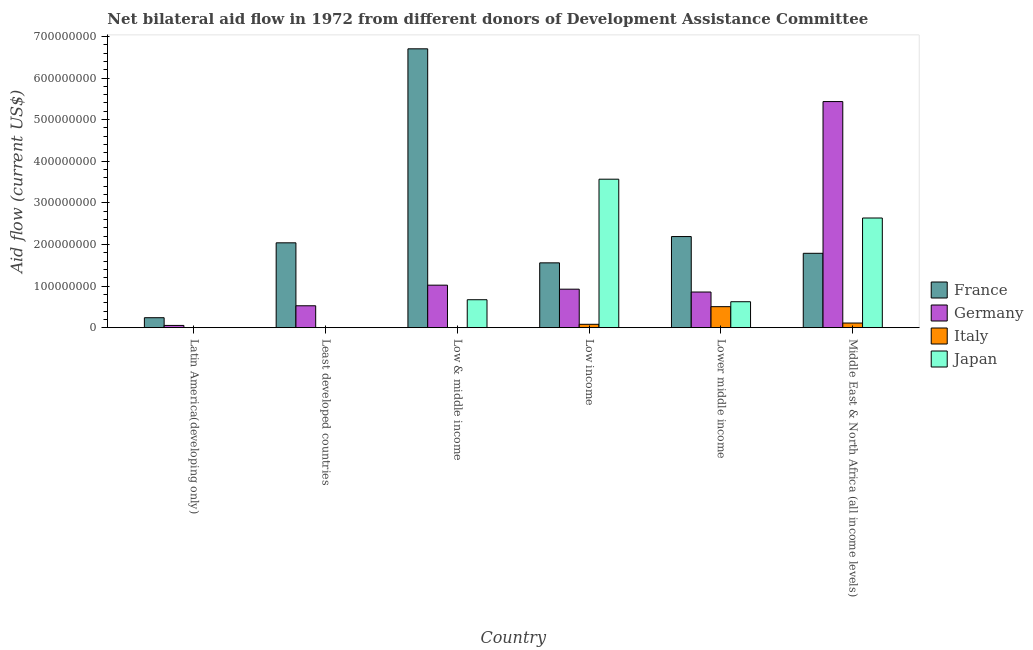How many different coloured bars are there?
Provide a succinct answer. 4. How many groups of bars are there?
Your response must be concise. 6. Are the number of bars on each tick of the X-axis equal?
Your answer should be very brief. No. How many bars are there on the 3rd tick from the right?
Provide a succinct answer. 4. What is the label of the 5th group of bars from the left?
Your answer should be compact. Lower middle income. What is the amount of aid given by italy in Latin America(developing only)?
Offer a very short reply. 1.80e+05. Across all countries, what is the maximum amount of aid given by france?
Provide a succinct answer. 6.70e+08. Across all countries, what is the minimum amount of aid given by italy?
Provide a short and direct response. 0. In which country was the amount of aid given by italy maximum?
Keep it short and to the point. Lower middle income. What is the total amount of aid given by japan in the graph?
Ensure brevity in your answer.  7.50e+08. What is the difference between the amount of aid given by japan in Lower middle income and that in Middle East & North Africa (all income levels)?
Provide a succinct answer. -2.01e+08. What is the difference between the amount of aid given by japan in Lower middle income and the amount of aid given by germany in Latin America(developing only)?
Provide a succinct answer. 5.70e+07. What is the average amount of aid given by germany per country?
Provide a succinct answer. 1.47e+08. What is the difference between the amount of aid given by germany and amount of aid given by japan in Middle East & North Africa (all income levels)?
Offer a terse response. 2.80e+08. In how many countries, is the amount of aid given by germany greater than 660000000 US$?
Give a very brief answer. 0. What is the ratio of the amount of aid given by germany in Lower middle income to that in Middle East & North Africa (all income levels)?
Keep it short and to the point. 0.16. Is the amount of aid given by germany in Least developed countries less than that in Low & middle income?
Give a very brief answer. Yes. What is the difference between the highest and the second highest amount of aid given by japan?
Your answer should be very brief. 9.33e+07. What is the difference between the highest and the lowest amount of aid given by germany?
Give a very brief answer. 5.38e+08. Is the sum of the amount of aid given by italy in Low income and Lower middle income greater than the maximum amount of aid given by germany across all countries?
Provide a short and direct response. No. Are all the bars in the graph horizontal?
Make the answer very short. No. How many countries are there in the graph?
Keep it short and to the point. 6. Does the graph contain any zero values?
Your answer should be compact. Yes. Does the graph contain grids?
Give a very brief answer. No. Where does the legend appear in the graph?
Ensure brevity in your answer.  Center right. How many legend labels are there?
Keep it short and to the point. 4. How are the legend labels stacked?
Your answer should be very brief. Vertical. What is the title of the graph?
Keep it short and to the point. Net bilateral aid flow in 1972 from different donors of Development Assistance Committee. What is the Aid flow (current US$) in France in Latin America(developing only)?
Your response must be concise. 2.39e+07. What is the Aid flow (current US$) of Germany in Latin America(developing only)?
Keep it short and to the point. 5.36e+06. What is the Aid flow (current US$) of France in Least developed countries?
Ensure brevity in your answer.  2.04e+08. What is the Aid flow (current US$) in Germany in Least developed countries?
Your answer should be compact. 5.26e+07. What is the Aid flow (current US$) in Italy in Least developed countries?
Your answer should be compact. 0. What is the Aid flow (current US$) in Japan in Least developed countries?
Provide a short and direct response. 0. What is the Aid flow (current US$) in France in Low & middle income?
Your response must be concise. 6.70e+08. What is the Aid flow (current US$) in Germany in Low & middle income?
Your response must be concise. 1.02e+08. What is the Aid flow (current US$) in Japan in Low & middle income?
Give a very brief answer. 6.71e+07. What is the Aid flow (current US$) of France in Low income?
Give a very brief answer. 1.56e+08. What is the Aid flow (current US$) of Germany in Low income?
Your response must be concise. 9.25e+07. What is the Aid flow (current US$) of Italy in Low income?
Your answer should be compact. 8.06e+06. What is the Aid flow (current US$) of Japan in Low income?
Offer a terse response. 3.57e+08. What is the Aid flow (current US$) of France in Lower middle income?
Offer a terse response. 2.19e+08. What is the Aid flow (current US$) of Germany in Lower middle income?
Your response must be concise. 8.56e+07. What is the Aid flow (current US$) in Italy in Lower middle income?
Offer a very short reply. 5.05e+07. What is the Aid flow (current US$) in Japan in Lower middle income?
Make the answer very short. 6.23e+07. What is the Aid flow (current US$) in France in Middle East & North Africa (all income levels)?
Keep it short and to the point. 1.79e+08. What is the Aid flow (current US$) of Germany in Middle East & North Africa (all income levels)?
Provide a short and direct response. 5.43e+08. What is the Aid flow (current US$) of Italy in Middle East & North Africa (all income levels)?
Provide a succinct answer. 1.11e+07. What is the Aid flow (current US$) in Japan in Middle East & North Africa (all income levels)?
Offer a terse response. 2.64e+08. Across all countries, what is the maximum Aid flow (current US$) in France?
Your answer should be compact. 6.70e+08. Across all countries, what is the maximum Aid flow (current US$) in Germany?
Provide a short and direct response. 5.43e+08. Across all countries, what is the maximum Aid flow (current US$) of Italy?
Provide a succinct answer. 5.05e+07. Across all countries, what is the maximum Aid flow (current US$) of Japan?
Ensure brevity in your answer.  3.57e+08. Across all countries, what is the minimum Aid flow (current US$) in France?
Your response must be concise. 2.39e+07. Across all countries, what is the minimum Aid flow (current US$) in Germany?
Ensure brevity in your answer.  5.36e+06. What is the total Aid flow (current US$) of France in the graph?
Provide a short and direct response. 1.45e+09. What is the total Aid flow (current US$) of Germany in the graph?
Keep it short and to the point. 8.82e+08. What is the total Aid flow (current US$) of Italy in the graph?
Your answer should be compact. 6.98e+07. What is the total Aid flow (current US$) in Japan in the graph?
Keep it short and to the point. 7.50e+08. What is the difference between the Aid flow (current US$) in France in Latin America(developing only) and that in Least developed countries?
Keep it short and to the point. -1.80e+08. What is the difference between the Aid flow (current US$) in Germany in Latin America(developing only) and that in Least developed countries?
Your response must be concise. -4.73e+07. What is the difference between the Aid flow (current US$) of France in Latin America(developing only) and that in Low & middle income?
Offer a very short reply. -6.46e+08. What is the difference between the Aid flow (current US$) in Germany in Latin America(developing only) and that in Low & middle income?
Make the answer very short. -9.68e+07. What is the difference between the Aid flow (current US$) of France in Latin America(developing only) and that in Low income?
Your answer should be very brief. -1.32e+08. What is the difference between the Aid flow (current US$) of Germany in Latin America(developing only) and that in Low income?
Make the answer very short. -8.71e+07. What is the difference between the Aid flow (current US$) in Italy in Latin America(developing only) and that in Low income?
Your answer should be compact. -7.88e+06. What is the difference between the Aid flow (current US$) in France in Latin America(developing only) and that in Lower middle income?
Provide a succinct answer. -1.95e+08. What is the difference between the Aid flow (current US$) of Germany in Latin America(developing only) and that in Lower middle income?
Your response must be concise. -8.03e+07. What is the difference between the Aid flow (current US$) of Italy in Latin America(developing only) and that in Lower middle income?
Your answer should be very brief. -5.03e+07. What is the difference between the Aid flow (current US$) in France in Latin America(developing only) and that in Middle East & North Africa (all income levels)?
Your answer should be compact. -1.55e+08. What is the difference between the Aid flow (current US$) in Germany in Latin America(developing only) and that in Middle East & North Africa (all income levels)?
Provide a short and direct response. -5.38e+08. What is the difference between the Aid flow (current US$) in Italy in Latin America(developing only) and that in Middle East & North Africa (all income levels)?
Your answer should be very brief. -1.09e+07. What is the difference between the Aid flow (current US$) of France in Least developed countries and that in Low & middle income?
Your response must be concise. -4.66e+08. What is the difference between the Aid flow (current US$) in Germany in Least developed countries and that in Low & middle income?
Your response must be concise. -4.95e+07. What is the difference between the Aid flow (current US$) in France in Least developed countries and that in Low income?
Your answer should be very brief. 4.81e+07. What is the difference between the Aid flow (current US$) in Germany in Least developed countries and that in Low income?
Your answer should be compact. -3.99e+07. What is the difference between the Aid flow (current US$) in France in Least developed countries and that in Lower middle income?
Offer a terse response. -1.51e+07. What is the difference between the Aid flow (current US$) of Germany in Least developed countries and that in Lower middle income?
Offer a very short reply. -3.30e+07. What is the difference between the Aid flow (current US$) in France in Least developed countries and that in Middle East & North Africa (all income levels)?
Offer a very short reply. 2.52e+07. What is the difference between the Aid flow (current US$) in Germany in Least developed countries and that in Middle East & North Africa (all income levels)?
Provide a short and direct response. -4.91e+08. What is the difference between the Aid flow (current US$) of France in Low & middle income and that in Low income?
Provide a short and direct response. 5.14e+08. What is the difference between the Aid flow (current US$) in Germany in Low & middle income and that in Low income?
Ensure brevity in your answer.  9.65e+06. What is the difference between the Aid flow (current US$) of Japan in Low & middle income and that in Low income?
Offer a very short reply. -2.90e+08. What is the difference between the Aid flow (current US$) of France in Low & middle income and that in Lower middle income?
Provide a succinct answer. 4.51e+08. What is the difference between the Aid flow (current US$) in Germany in Low & middle income and that in Lower middle income?
Your answer should be very brief. 1.65e+07. What is the difference between the Aid flow (current US$) in Japan in Low & middle income and that in Lower middle income?
Offer a very short reply. 4.79e+06. What is the difference between the Aid flow (current US$) in France in Low & middle income and that in Middle East & North Africa (all income levels)?
Keep it short and to the point. 4.91e+08. What is the difference between the Aid flow (current US$) of Germany in Low & middle income and that in Middle East & North Africa (all income levels)?
Keep it short and to the point. -4.41e+08. What is the difference between the Aid flow (current US$) in Japan in Low & middle income and that in Middle East & North Africa (all income levels)?
Provide a short and direct response. -1.96e+08. What is the difference between the Aid flow (current US$) of France in Low income and that in Lower middle income?
Offer a terse response. -6.32e+07. What is the difference between the Aid flow (current US$) in Germany in Low income and that in Lower middle income?
Ensure brevity in your answer.  6.86e+06. What is the difference between the Aid flow (current US$) in Italy in Low income and that in Lower middle income?
Provide a short and direct response. -4.24e+07. What is the difference between the Aid flow (current US$) in Japan in Low income and that in Lower middle income?
Give a very brief answer. 2.94e+08. What is the difference between the Aid flow (current US$) in France in Low income and that in Middle East & North Africa (all income levels)?
Make the answer very short. -2.29e+07. What is the difference between the Aid flow (current US$) of Germany in Low income and that in Middle East & North Africa (all income levels)?
Provide a short and direct response. -4.51e+08. What is the difference between the Aid flow (current US$) in Italy in Low income and that in Middle East & North Africa (all income levels)?
Make the answer very short. -3.04e+06. What is the difference between the Aid flow (current US$) of Japan in Low income and that in Middle East & North Africa (all income levels)?
Offer a very short reply. 9.33e+07. What is the difference between the Aid flow (current US$) of France in Lower middle income and that in Middle East & North Africa (all income levels)?
Give a very brief answer. 4.03e+07. What is the difference between the Aid flow (current US$) in Germany in Lower middle income and that in Middle East & North Africa (all income levels)?
Ensure brevity in your answer.  -4.58e+08. What is the difference between the Aid flow (current US$) of Italy in Lower middle income and that in Middle East & North Africa (all income levels)?
Keep it short and to the point. 3.94e+07. What is the difference between the Aid flow (current US$) of Japan in Lower middle income and that in Middle East & North Africa (all income levels)?
Your answer should be very brief. -2.01e+08. What is the difference between the Aid flow (current US$) in France in Latin America(developing only) and the Aid flow (current US$) in Germany in Least developed countries?
Your answer should be very brief. -2.87e+07. What is the difference between the Aid flow (current US$) in France in Latin America(developing only) and the Aid flow (current US$) in Germany in Low & middle income?
Provide a succinct answer. -7.82e+07. What is the difference between the Aid flow (current US$) in France in Latin America(developing only) and the Aid flow (current US$) in Japan in Low & middle income?
Keep it short and to the point. -4.32e+07. What is the difference between the Aid flow (current US$) in Germany in Latin America(developing only) and the Aid flow (current US$) in Japan in Low & middle income?
Make the answer very short. -6.18e+07. What is the difference between the Aid flow (current US$) of Italy in Latin America(developing only) and the Aid flow (current US$) of Japan in Low & middle income?
Offer a terse response. -6.70e+07. What is the difference between the Aid flow (current US$) of France in Latin America(developing only) and the Aid flow (current US$) of Germany in Low income?
Keep it short and to the point. -6.86e+07. What is the difference between the Aid flow (current US$) in France in Latin America(developing only) and the Aid flow (current US$) in Italy in Low income?
Your answer should be very brief. 1.59e+07. What is the difference between the Aid flow (current US$) in France in Latin America(developing only) and the Aid flow (current US$) in Japan in Low income?
Keep it short and to the point. -3.33e+08. What is the difference between the Aid flow (current US$) in Germany in Latin America(developing only) and the Aid flow (current US$) in Italy in Low income?
Ensure brevity in your answer.  -2.70e+06. What is the difference between the Aid flow (current US$) in Germany in Latin America(developing only) and the Aid flow (current US$) in Japan in Low income?
Your response must be concise. -3.51e+08. What is the difference between the Aid flow (current US$) in Italy in Latin America(developing only) and the Aid flow (current US$) in Japan in Low income?
Offer a terse response. -3.57e+08. What is the difference between the Aid flow (current US$) of France in Latin America(developing only) and the Aid flow (current US$) of Germany in Lower middle income?
Make the answer very short. -6.17e+07. What is the difference between the Aid flow (current US$) in France in Latin America(developing only) and the Aid flow (current US$) in Italy in Lower middle income?
Keep it short and to the point. -2.65e+07. What is the difference between the Aid flow (current US$) of France in Latin America(developing only) and the Aid flow (current US$) of Japan in Lower middle income?
Make the answer very short. -3.84e+07. What is the difference between the Aid flow (current US$) in Germany in Latin America(developing only) and the Aid flow (current US$) in Italy in Lower middle income?
Make the answer very short. -4.51e+07. What is the difference between the Aid flow (current US$) of Germany in Latin America(developing only) and the Aid flow (current US$) of Japan in Lower middle income?
Offer a terse response. -5.70e+07. What is the difference between the Aid flow (current US$) of Italy in Latin America(developing only) and the Aid flow (current US$) of Japan in Lower middle income?
Keep it short and to the point. -6.22e+07. What is the difference between the Aid flow (current US$) in France in Latin America(developing only) and the Aid flow (current US$) in Germany in Middle East & North Africa (all income levels)?
Keep it short and to the point. -5.19e+08. What is the difference between the Aid flow (current US$) in France in Latin America(developing only) and the Aid flow (current US$) in Italy in Middle East & North Africa (all income levels)?
Offer a very short reply. 1.28e+07. What is the difference between the Aid flow (current US$) in France in Latin America(developing only) and the Aid flow (current US$) in Japan in Middle East & North Africa (all income levels)?
Make the answer very short. -2.40e+08. What is the difference between the Aid flow (current US$) in Germany in Latin America(developing only) and the Aid flow (current US$) in Italy in Middle East & North Africa (all income levels)?
Your answer should be compact. -5.74e+06. What is the difference between the Aid flow (current US$) of Germany in Latin America(developing only) and the Aid flow (current US$) of Japan in Middle East & North Africa (all income levels)?
Offer a very short reply. -2.58e+08. What is the difference between the Aid flow (current US$) in Italy in Latin America(developing only) and the Aid flow (current US$) in Japan in Middle East & North Africa (all income levels)?
Your answer should be compact. -2.63e+08. What is the difference between the Aid flow (current US$) in France in Least developed countries and the Aid flow (current US$) in Germany in Low & middle income?
Keep it short and to the point. 1.02e+08. What is the difference between the Aid flow (current US$) in France in Least developed countries and the Aid flow (current US$) in Japan in Low & middle income?
Offer a terse response. 1.37e+08. What is the difference between the Aid flow (current US$) of Germany in Least developed countries and the Aid flow (current US$) of Japan in Low & middle income?
Provide a succinct answer. -1.45e+07. What is the difference between the Aid flow (current US$) of France in Least developed countries and the Aid flow (current US$) of Germany in Low income?
Your answer should be compact. 1.11e+08. What is the difference between the Aid flow (current US$) of France in Least developed countries and the Aid flow (current US$) of Italy in Low income?
Ensure brevity in your answer.  1.96e+08. What is the difference between the Aid flow (current US$) of France in Least developed countries and the Aid flow (current US$) of Japan in Low income?
Your response must be concise. -1.53e+08. What is the difference between the Aid flow (current US$) of Germany in Least developed countries and the Aid flow (current US$) of Italy in Low income?
Provide a short and direct response. 4.46e+07. What is the difference between the Aid flow (current US$) of Germany in Least developed countries and the Aid flow (current US$) of Japan in Low income?
Your answer should be very brief. -3.04e+08. What is the difference between the Aid flow (current US$) in France in Least developed countries and the Aid flow (current US$) in Germany in Lower middle income?
Give a very brief answer. 1.18e+08. What is the difference between the Aid flow (current US$) in France in Least developed countries and the Aid flow (current US$) in Italy in Lower middle income?
Ensure brevity in your answer.  1.53e+08. What is the difference between the Aid flow (current US$) in France in Least developed countries and the Aid flow (current US$) in Japan in Lower middle income?
Offer a terse response. 1.42e+08. What is the difference between the Aid flow (current US$) in Germany in Least developed countries and the Aid flow (current US$) in Italy in Lower middle income?
Provide a succinct answer. 2.16e+06. What is the difference between the Aid flow (current US$) in Germany in Least developed countries and the Aid flow (current US$) in Japan in Lower middle income?
Offer a terse response. -9.72e+06. What is the difference between the Aid flow (current US$) in France in Least developed countries and the Aid flow (current US$) in Germany in Middle East & North Africa (all income levels)?
Offer a very short reply. -3.39e+08. What is the difference between the Aid flow (current US$) of France in Least developed countries and the Aid flow (current US$) of Italy in Middle East & North Africa (all income levels)?
Ensure brevity in your answer.  1.93e+08. What is the difference between the Aid flow (current US$) of France in Least developed countries and the Aid flow (current US$) of Japan in Middle East & North Africa (all income levels)?
Your response must be concise. -5.96e+07. What is the difference between the Aid flow (current US$) of Germany in Least developed countries and the Aid flow (current US$) of Italy in Middle East & North Africa (all income levels)?
Your answer should be compact. 4.15e+07. What is the difference between the Aid flow (current US$) of Germany in Least developed countries and the Aid flow (current US$) of Japan in Middle East & North Africa (all income levels)?
Offer a very short reply. -2.11e+08. What is the difference between the Aid flow (current US$) in France in Low & middle income and the Aid flow (current US$) in Germany in Low income?
Offer a very short reply. 5.78e+08. What is the difference between the Aid flow (current US$) of France in Low & middle income and the Aid flow (current US$) of Italy in Low income?
Provide a short and direct response. 6.62e+08. What is the difference between the Aid flow (current US$) in France in Low & middle income and the Aid flow (current US$) in Japan in Low income?
Give a very brief answer. 3.13e+08. What is the difference between the Aid flow (current US$) of Germany in Low & middle income and the Aid flow (current US$) of Italy in Low income?
Your response must be concise. 9.41e+07. What is the difference between the Aid flow (current US$) in Germany in Low & middle income and the Aid flow (current US$) in Japan in Low income?
Keep it short and to the point. -2.55e+08. What is the difference between the Aid flow (current US$) in France in Low & middle income and the Aid flow (current US$) in Germany in Lower middle income?
Ensure brevity in your answer.  5.85e+08. What is the difference between the Aid flow (current US$) in France in Low & middle income and the Aid flow (current US$) in Italy in Lower middle income?
Provide a succinct answer. 6.20e+08. What is the difference between the Aid flow (current US$) in France in Low & middle income and the Aid flow (current US$) in Japan in Lower middle income?
Your response must be concise. 6.08e+08. What is the difference between the Aid flow (current US$) of Germany in Low & middle income and the Aid flow (current US$) of Italy in Lower middle income?
Offer a terse response. 5.17e+07. What is the difference between the Aid flow (current US$) of Germany in Low & middle income and the Aid flow (current US$) of Japan in Lower middle income?
Keep it short and to the point. 3.98e+07. What is the difference between the Aid flow (current US$) of France in Low & middle income and the Aid flow (current US$) of Germany in Middle East & North Africa (all income levels)?
Your response must be concise. 1.27e+08. What is the difference between the Aid flow (current US$) in France in Low & middle income and the Aid flow (current US$) in Italy in Middle East & North Africa (all income levels)?
Offer a very short reply. 6.59e+08. What is the difference between the Aid flow (current US$) in France in Low & middle income and the Aid flow (current US$) in Japan in Middle East & North Africa (all income levels)?
Offer a very short reply. 4.07e+08. What is the difference between the Aid flow (current US$) in Germany in Low & middle income and the Aid flow (current US$) in Italy in Middle East & North Africa (all income levels)?
Make the answer very short. 9.10e+07. What is the difference between the Aid flow (current US$) of Germany in Low & middle income and the Aid flow (current US$) of Japan in Middle East & North Africa (all income levels)?
Your answer should be very brief. -1.61e+08. What is the difference between the Aid flow (current US$) in France in Low income and the Aid flow (current US$) in Germany in Lower middle income?
Your answer should be very brief. 7.02e+07. What is the difference between the Aid flow (current US$) in France in Low income and the Aid flow (current US$) in Italy in Lower middle income?
Provide a succinct answer. 1.05e+08. What is the difference between the Aid flow (current US$) in France in Low income and the Aid flow (current US$) in Japan in Lower middle income?
Make the answer very short. 9.34e+07. What is the difference between the Aid flow (current US$) in Germany in Low income and the Aid flow (current US$) in Italy in Lower middle income?
Provide a short and direct response. 4.20e+07. What is the difference between the Aid flow (current US$) of Germany in Low income and the Aid flow (current US$) of Japan in Lower middle income?
Your response must be concise. 3.02e+07. What is the difference between the Aid flow (current US$) of Italy in Low income and the Aid flow (current US$) of Japan in Lower middle income?
Make the answer very short. -5.43e+07. What is the difference between the Aid flow (current US$) in France in Low income and the Aid flow (current US$) in Germany in Middle East & North Africa (all income levels)?
Ensure brevity in your answer.  -3.88e+08. What is the difference between the Aid flow (current US$) in France in Low income and the Aid flow (current US$) in Italy in Middle East & North Africa (all income levels)?
Offer a terse response. 1.45e+08. What is the difference between the Aid flow (current US$) in France in Low income and the Aid flow (current US$) in Japan in Middle East & North Africa (all income levels)?
Provide a succinct answer. -1.08e+08. What is the difference between the Aid flow (current US$) of Germany in Low income and the Aid flow (current US$) of Italy in Middle East & North Africa (all income levels)?
Provide a short and direct response. 8.14e+07. What is the difference between the Aid flow (current US$) of Germany in Low income and the Aid flow (current US$) of Japan in Middle East & North Africa (all income levels)?
Offer a very short reply. -1.71e+08. What is the difference between the Aid flow (current US$) of Italy in Low income and the Aid flow (current US$) of Japan in Middle East & North Africa (all income levels)?
Your answer should be very brief. -2.55e+08. What is the difference between the Aid flow (current US$) of France in Lower middle income and the Aid flow (current US$) of Germany in Middle East & North Africa (all income levels)?
Your answer should be compact. -3.24e+08. What is the difference between the Aid flow (current US$) of France in Lower middle income and the Aid flow (current US$) of Italy in Middle East & North Africa (all income levels)?
Offer a terse response. 2.08e+08. What is the difference between the Aid flow (current US$) in France in Lower middle income and the Aid flow (current US$) in Japan in Middle East & North Africa (all income levels)?
Offer a very short reply. -4.46e+07. What is the difference between the Aid flow (current US$) in Germany in Lower middle income and the Aid flow (current US$) in Italy in Middle East & North Africa (all income levels)?
Ensure brevity in your answer.  7.45e+07. What is the difference between the Aid flow (current US$) in Germany in Lower middle income and the Aid flow (current US$) in Japan in Middle East & North Africa (all income levels)?
Provide a short and direct response. -1.78e+08. What is the difference between the Aid flow (current US$) in Italy in Lower middle income and the Aid flow (current US$) in Japan in Middle East & North Africa (all income levels)?
Offer a very short reply. -2.13e+08. What is the average Aid flow (current US$) in France per country?
Give a very brief answer. 2.42e+08. What is the average Aid flow (current US$) of Germany per country?
Provide a short and direct response. 1.47e+08. What is the average Aid flow (current US$) in Italy per country?
Your response must be concise. 1.16e+07. What is the average Aid flow (current US$) of Japan per country?
Ensure brevity in your answer.  1.25e+08. What is the difference between the Aid flow (current US$) of France and Aid flow (current US$) of Germany in Latin America(developing only)?
Offer a terse response. 1.86e+07. What is the difference between the Aid flow (current US$) in France and Aid flow (current US$) in Italy in Latin America(developing only)?
Ensure brevity in your answer.  2.37e+07. What is the difference between the Aid flow (current US$) in Germany and Aid flow (current US$) in Italy in Latin America(developing only)?
Offer a very short reply. 5.18e+06. What is the difference between the Aid flow (current US$) in France and Aid flow (current US$) in Germany in Least developed countries?
Make the answer very short. 1.51e+08. What is the difference between the Aid flow (current US$) in France and Aid flow (current US$) in Germany in Low & middle income?
Provide a succinct answer. 5.68e+08. What is the difference between the Aid flow (current US$) in France and Aid flow (current US$) in Japan in Low & middle income?
Give a very brief answer. 6.03e+08. What is the difference between the Aid flow (current US$) of Germany and Aid flow (current US$) of Japan in Low & middle income?
Your answer should be compact. 3.50e+07. What is the difference between the Aid flow (current US$) in France and Aid flow (current US$) in Germany in Low income?
Your response must be concise. 6.33e+07. What is the difference between the Aid flow (current US$) in France and Aid flow (current US$) in Italy in Low income?
Your answer should be compact. 1.48e+08. What is the difference between the Aid flow (current US$) of France and Aid flow (current US$) of Japan in Low income?
Provide a succinct answer. -2.01e+08. What is the difference between the Aid flow (current US$) of Germany and Aid flow (current US$) of Italy in Low income?
Offer a terse response. 8.44e+07. What is the difference between the Aid flow (current US$) of Germany and Aid flow (current US$) of Japan in Low income?
Your answer should be very brief. -2.64e+08. What is the difference between the Aid flow (current US$) of Italy and Aid flow (current US$) of Japan in Low income?
Your answer should be very brief. -3.49e+08. What is the difference between the Aid flow (current US$) in France and Aid flow (current US$) in Germany in Lower middle income?
Your answer should be very brief. 1.33e+08. What is the difference between the Aid flow (current US$) of France and Aid flow (current US$) of Italy in Lower middle income?
Your answer should be compact. 1.69e+08. What is the difference between the Aid flow (current US$) in France and Aid flow (current US$) in Japan in Lower middle income?
Give a very brief answer. 1.57e+08. What is the difference between the Aid flow (current US$) of Germany and Aid flow (current US$) of Italy in Lower middle income?
Provide a short and direct response. 3.52e+07. What is the difference between the Aid flow (current US$) in Germany and Aid flow (current US$) in Japan in Lower middle income?
Offer a terse response. 2.33e+07. What is the difference between the Aid flow (current US$) in Italy and Aid flow (current US$) in Japan in Lower middle income?
Your answer should be very brief. -1.19e+07. What is the difference between the Aid flow (current US$) in France and Aid flow (current US$) in Germany in Middle East & North Africa (all income levels)?
Keep it short and to the point. -3.65e+08. What is the difference between the Aid flow (current US$) of France and Aid flow (current US$) of Italy in Middle East & North Africa (all income levels)?
Your answer should be compact. 1.68e+08. What is the difference between the Aid flow (current US$) in France and Aid flow (current US$) in Japan in Middle East & North Africa (all income levels)?
Keep it short and to the point. -8.48e+07. What is the difference between the Aid flow (current US$) of Germany and Aid flow (current US$) of Italy in Middle East & North Africa (all income levels)?
Keep it short and to the point. 5.32e+08. What is the difference between the Aid flow (current US$) in Germany and Aid flow (current US$) in Japan in Middle East & North Africa (all income levels)?
Make the answer very short. 2.80e+08. What is the difference between the Aid flow (current US$) in Italy and Aid flow (current US$) in Japan in Middle East & North Africa (all income levels)?
Keep it short and to the point. -2.52e+08. What is the ratio of the Aid flow (current US$) of France in Latin America(developing only) to that in Least developed countries?
Keep it short and to the point. 0.12. What is the ratio of the Aid flow (current US$) of Germany in Latin America(developing only) to that in Least developed countries?
Offer a very short reply. 0.1. What is the ratio of the Aid flow (current US$) of France in Latin America(developing only) to that in Low & middle income?
Ensure brevity in your answer.  0.04. What is the ratio of the Aid flow (current US$) in Germany in Latin America(developing only) to that in Low & middle income?
Ensure brevity in your answer.  0.05. What is the ratio of the Aid flow (current US$) of France in Latin America(developing only) to that in Low income?
Provide a succinct answer. 0.15. What is the ratio of the Aid flow (current US$) in Germany in Latin America(developing only) to that in Low income?
Make the answer very short. 0.06. What is the ratio of the Aid flow (current US$) of Italy in Latin America(developing only) to that in Low income?
Offer a terse response. 0.02. What is the ratio of the Aid flow (current US$) of France in Latin America(developing only) to that in Lower middle income?
Offer a terse response. 0.11. What is the ratio of the Aid flow (current US$) of Germany in Latin America(developing only) to that in Lower middle income?
Your answer should be very brief. 0.06. What is the ratio of the Aid flow (current US$) of Italy in Latin America(developing only) to that in Lower middle income?
Offer a very short reply. 0. What is the ratio of the Aid flow (current US$) of France in Latin America(developing only) to that in Middle East & North Africa (all income levels)?
Ensure brevity in your answer.  0.13. What is the ratio of the Aid flow (current US$) in Germany in Latin America(developing only) to that in Middle East & North Africa (all income levels)?
Offer a terse response. 0.01. What is the ratio of the Aid flow (current US$) of Italy in Latin America(developing only) to that in Middle East & North Africa (all income levels)?
Provide a short and direct response. 0.02. What is the ratio of the Aid flow (current US$) of France in Least developed countries to that in Low & middle income?
Provide a short and direct response. 0.3. What is the ratio of the Aid flow (current US$) of Germany in Least developed countries to that in Low & middle income?
Your response must be concise. 0.52. What is the ratio of the Aid flow (current US$) in France in Least developed countries to that in Low income?
Your answer should be very brief. 1.31. What is the ratio of the Aid flow (current US$) in Germany in Least developed countries to that in Low income?
Provide a succinct answer. 0.57. What is the ratio of the Aid flow (current US$) in France in Least developed countries to that in Lower middle income?
Provide a short and direct response. 0.93. What is the ratio of the Aid flow (current US$) in Germany in Least developed countries to that in Lower middle income?
Your answer should be very brief. 0.61. What is the ratio of the Aid flow (current US$) of France in Least developed countries to that in Middle East & North Africa (all income levels)?
Your answer should be very brief. 1.14. What is the ratio of the Aid flow (current US$) in Germany in Least developed countries to that in Middle East & North Africa (all income levels)?
Your response must be concise. 0.1. What is the ratio of the Aid flow (current US$) in France in Low & middle income to that in Low income?
Provide a succinct answer. 4.3. What is the ratio of the Aid flow (current US$) in Germany in Low & middle income to that in Low income?
Keep it short and to the point. 1.1. What is the ratio of the Aid flow (current US$) in Japan in Low & middle income to that in Low income?
Your answer should be very brief. 0.19. What is the ratio of the Aid flow (current US$) in France in Low & middle income to that in Lower middle income?
Your response must be concise. 3.06. What is the ratio of the Aid flow (current US$) in Germany in Low & middle income to that in Lower middle income?
Your answer should be compact. 1.19. What is the ratio of the Aid flow (current US$) of Japan in Low & middle income to that in Lower middle income?
Make the answer very short. 1.08. What is the ratio of the Aid flow (current US$) of France in Low & middle income to that in Middle East & North Africa (all income levels)?
Ensure brevity in your answer.  3.75. What is the ratio of the Aid flow (current US$) of Germany in Low & middle income to that in Middle East & North Africa (all income levels)?
Your answer should be very brief. 0.19. What is the ratio of the Aid flow (current US$) of Japan in Low & middle income to that in Middle East & North Africa (all income levels)?
Make the answer very short. 0.25. What is the ratio of the Aid flow (current US$) in France in Low income to that in Lower middle income?
Make the answer very short. 0.71. What is the ratio of the Aid flow (current US$) in Germany in Low income to that in Lower middle income?
Keep it short and to the point. 1.08. What is the ratio of the Aid flow (current US$) of Italy in Low income to that in Lower middle income?
Make the answer very short. 0.16. What is the ratio of the Aid flow (current US$) in Japan in Low income to that in Lower middle income?
Keep it short and to the point. 5.72. What is the ratio of the Aid flow (current US$) of France in Low income to that in Middle East & North Africa (all income levels)?
Provide a succinct answer. 0.87. What is the ratio of the Aid flow (current US$) of Germany in Low income to that in Middle East & North Africa (all income levels)?
Your answer should be very brief. 0.17. What is the ratio of the Aid flow (current US$) in Italy in Low income to that in Middle East & North Africa (all income levels)?
Provide a short and direct response. 0.73. What is the ratio of the Aid flow (current US$) in Japan in Low income to that in Middle East & North Africa (all income levels)?
Ensure brevity in your answer.  1.35. What is the ratio of the Aid flow (current US$) of France in Lower middle income to that in Middle East & North Africa (all income levels)?
Offer a very short reply. 1.23. What is the ratio of the Aid flow (current US$) in Germany in Lower middle income to that in Middle East & North Africa (all income levels)?
Your answer should be very brief. 0.16. What is the ratio of the Aid flow (current US$) of Italy in Lower middle income to that in Middle East & North Africa (all income levels)?
Your answer should be compact. 4.55. What is the ratio of the Aid flow (current US$) in Japan in Lower middle income to that in Middle East & North Africa (all income levels)?
Keep it short and to the point. 0.24. What is the difference between the highest and the second highest Aid flow (current US$) of France?
Offer a very short reply. 4.51e+08. What is the difference between the highest and the second highest Aid flow (current US$) in Germany?
Provide a succinct answer. 4.41e+08. What is the difference between the highest and the second highest Aid flow (current US$) of Italy?
Provide a short and direct response. 3.94e+07. What is the difference between the highest and the second highest Aid flow (current US$) in Japan?
Provide a succinct answer. 9.33e+07. What is the difference between the highest and the lowest Aid flow (current US$) in France?
Provide a short and direct response. 6.46e+08. What is the difference between the highest and the lowest Aid flow (current US$) in Germany?
Make the answer very short. 5.38e+08. What is the difference between the highest and the lowest Aid flow (current US$) of Italy?
Offer a terse response. 5.05e+07. What is the difference between the highest and the lowest Aid flow (current US$) of Japan?
Ensure brevity in your answer.  3.57e+08. 